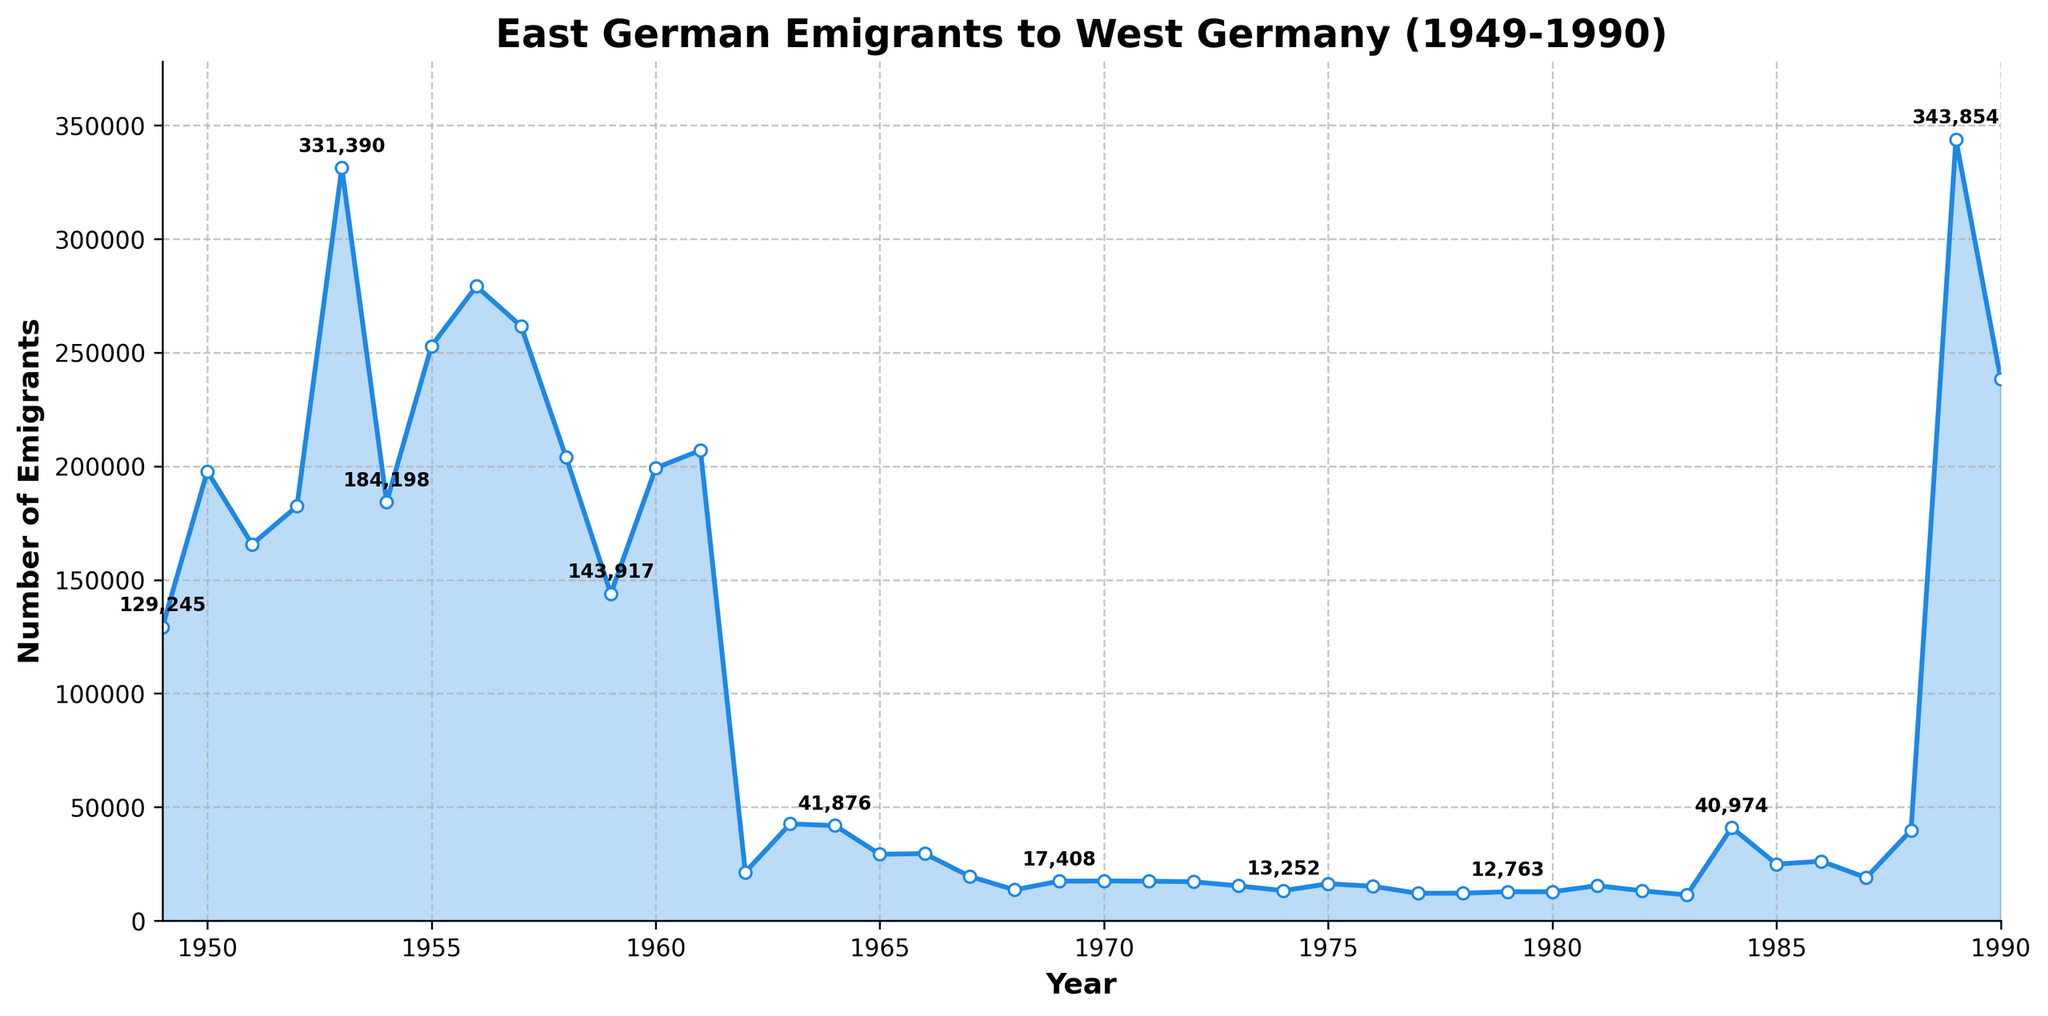What is the peak number of East German emigrants to West Germany during the given period? The two tallest points on the chart are in 1953 and 1989. By examining the y-axis labels and annotations, we see that the highest number occurs in 1989 with 343,854 emigrants.
Answer: 343,854 What was the trend in emigrants after 1961? In 1961, emigrants sharply decreased from around 200,000 to about 20,000 in 1962. After 1961, the numbers remained relatively low, typically below 30,000 emigrants per year until a significant spike in 1989.
Answer: Decreased and remained low Which year had the largest drop in the number of emigrants compared to the previous year? Examine the line connecting each year to identify the steepest downward slope. This steepest decline occurs from 1961 (207,026 emigrants) to 1962 (21,365 emigrants), a drop of 185,661.
Answer: 1962 Compare the number of emigrants in 1953 and 1989. Which year had more, and by how much? The number of emigrants in 1953 was 331,390, while in 1989 it was 343,854. Subtracting these values, 1989 had 12,464 more emigrants than 1953.
Answer: 1989, 12,464 What seems to happen to the number of emigrants after the Berlin Wall's erection in 1961? After 1961, there was a sharp decline in the number of emigrants from 207,026 in 1961 to 21,365 in 1962, and the numbers remained consistently lower compared to pre-1961 until 1989.
Answer: Decreased sharply How does the number of emigrants in 1990 compare to that in 1955? The number of emigrants in 1990 was 238,384, and in 1955 it was 252,870. Comparing these values, 1955 had more emigrants.
Answer: 1955 had more Calculate the average number of emigrants per year for the decade of the 1950s. Sum the emigrant values from 1950-1959 and divide by 10. (197,788 + 165,648 + 182,393 + 331,390 + 184,198 + 252,870 + 279,189 + 261,622 + 204,092 + 143,917) / 10 = 220,311 (rounded to nearest whole number).
Answer: 220,311 Identify the visual cue indicating a significant historical event affecting emigration in 1961. The most noticeable visual feature is the drastic drop in the line charted between 1961 and 1962. The steep decline indicates the impact of the Berlin Wall's construction in 1961.
Answer: Steep decline Would you consider the emigration pattern before and after 1961 drastically different? Support your answer with visual evidence. Yes, before 1961, the emigration levels were much higher, frequently exceeding 100,000. After 1961, there is a sharp decline to levels mostly below 30,000, indicating a drastic change.
Answer: Yes, drastically different 